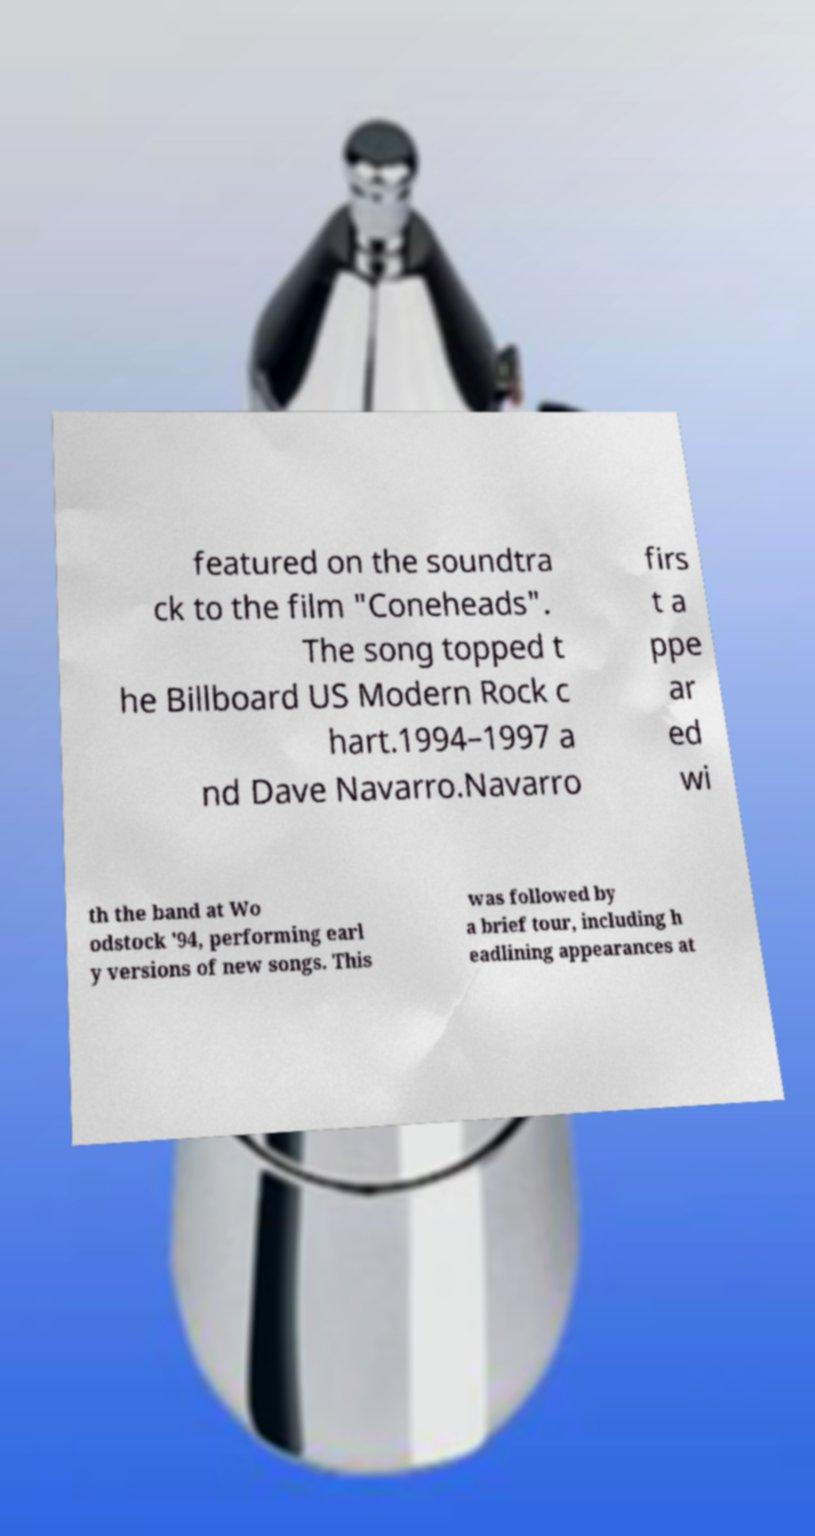For documentation purposes, I need the text within this image transcribed. Could you provide that? featured on the soundtra ck to the film "Coneheads". The song topped t he Billboard US Modern Rock c hart.1994–1997 a nd Dave Navarro.Navarro firs t a ppe ar ed wi th the band at Wo odstock '94, performing earl y versions of new songs. This was followed by a brief tour, including h eadlining appearances at 